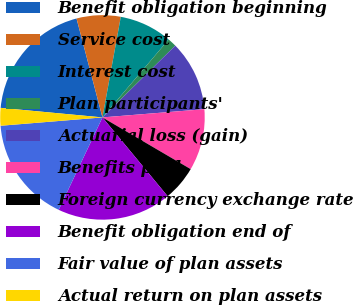Convert chart. <chart><loc_0><loc_0><loc_500><loc_500><pie_chart><fcel>Benefit obligation beginning<fcel>Service cost<fcel>Interest cost<fcel>Plan participants'<fcel>Actuarial loss (gain)<fcel>Benefits paid<fcel>Foreign currency exchange rate<fcel>Benefit obligation end of<fcel>Fair value of plan assets<fcel>Actual return on plan assets<nl><fcel>19.43%<fcel>6.95%<fcel>8.34%<fcel>1.4%<fcel>11.11%<fcel>9.72%<fcel>5.56%<fcel>18.04%<fcel>16.66%<fcel>2.79%<nl></chart> 